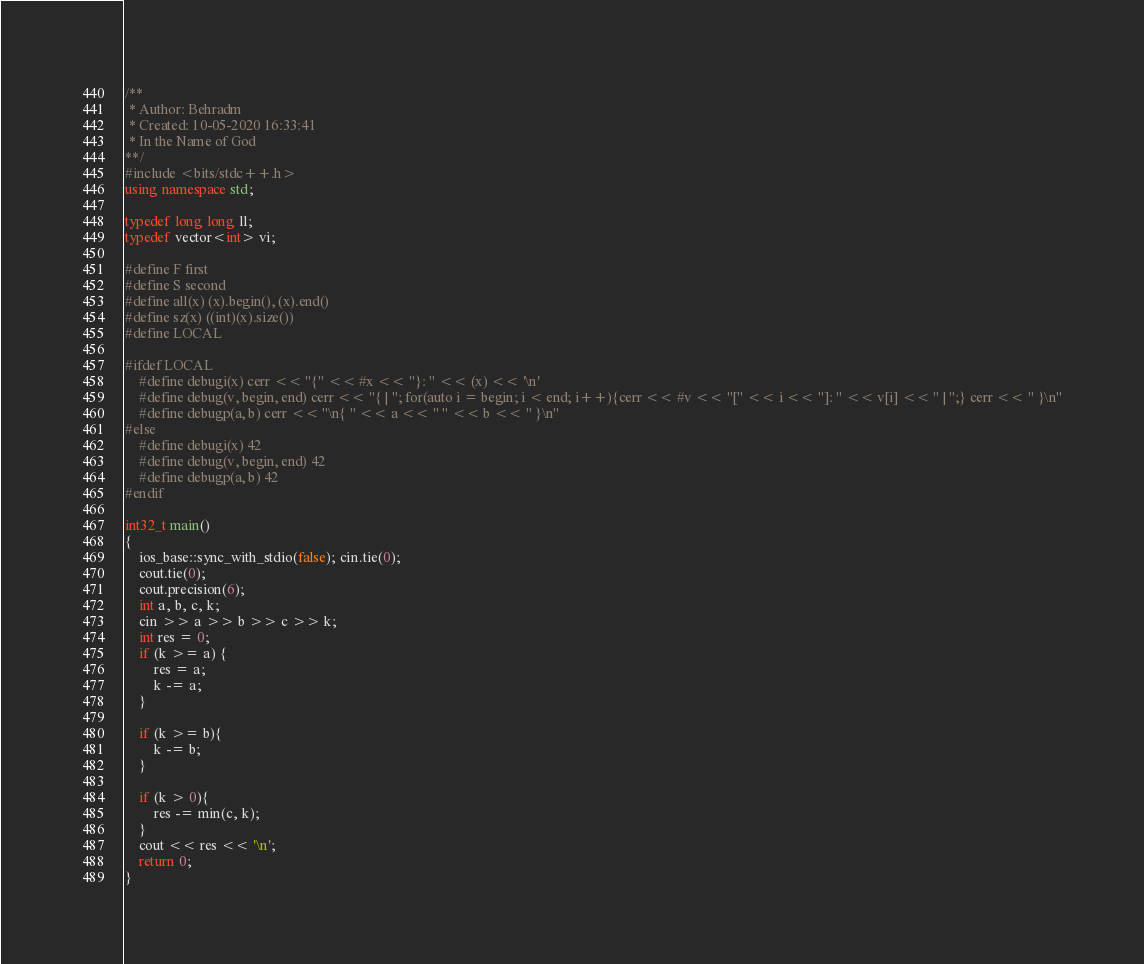Convert code to text. <code><loc_0><loc_0><loc_500><loc_500><_C++_>/**
 * Author: Behradm
 * Created: 10-05-2020 16:33:41
 * In the Name of God
**/
#include <bits/stdc++.h>
using namespace std;

typedef long long ll;
typedef vector<int> vi;

#define F first
#define S second
#define all(x) (x).begin(), (x).end()
#define sz(x) ((int)(x).size())
#define LOCAL

#ifdef LOCAL
	#define debugi(x) cerr << "{" << #x << "}: " << (x) << '\n'
	#define debug(v, begin, end) cerr << "{ | "; for(auto i = begin; i < end; i++){cerr << #v << "[" << i << "]: " << v[i] << " | ";} cerr << " }\n"
	#define debugp(a, b) cerr << "\n{ " << a << " " << b << " }\n"
#else
	#define debugi(x) 42
	#define debug(v, begin, end) 42
	#define debugp(a, b) 42 
#endif

int32_t main()
{
	ios_base::sync_with_stdio(false); cin.tie(0);
	cout.tie(0);
	cout.precision(6);
	int a, b, c, k;
	cin >> a >> b >> c >> k;
	int res = 0;
	if (k >= a) {
		res = a;
		k -= a;
	}

	if (k >= b){
		k -= b;
	}

	if (k > 0){
		res -= min(c, k);
	}
	cout << res << '\n';
	return 0;
}

</code> 